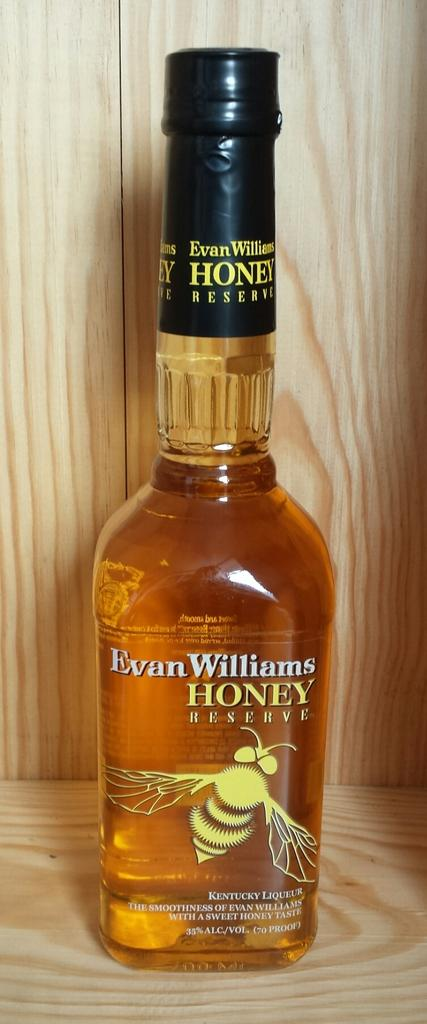<image>
Offer a succinct explanation of the picture presented. An unopened bottle of Evan Williams Honey Reserve whiskey. 